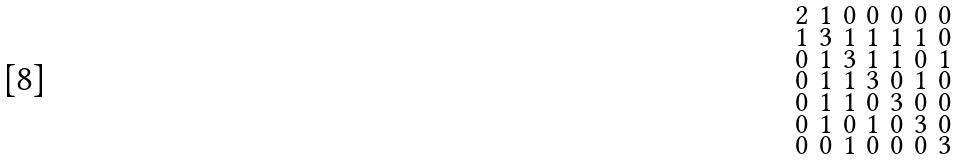Convert formula to latex. <formula><loc_0><loc_0><loc_500><loc_500>\begin{smallmatrix} 2 & 1 & 0 & 0 & 0 & 0 & 0 \\ 1 & 3 & 1 & 1 & 1 & 1 & 0 \\ 0 & 1 & 3 & 1 & 1 & 0 & 1 \\ 0 & 1 & 1 & 3 & 0 & 1 & 0 \\ 0 & 1 & 1 & 0 & 3 & 0 & 0 \\ 0 & 1 & 0 & 1 & 0 & 3 & 0 \\ 0 & 0 & 1 & 0 & 0 & 0 & 3 \end{smallmatrix}</formula> 